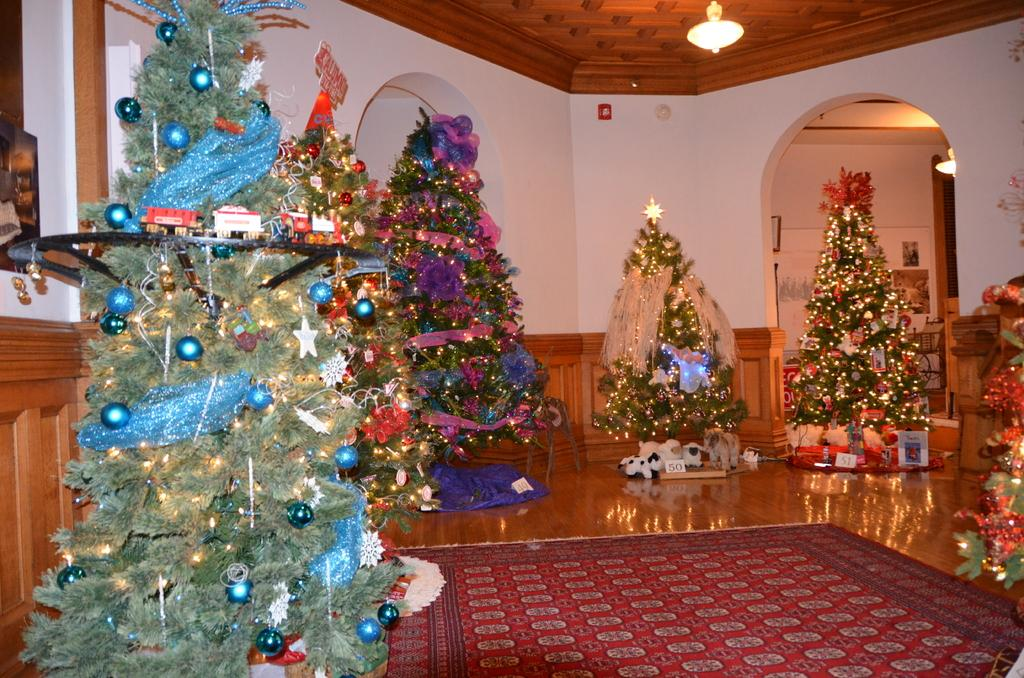What type of decorations are present in the image? There are Christmas trees in the image. What is located at the bottom of the image? There is a carpet at the bottom of the image. Where is the light source in the image? There is a light on the ceiling, which is at the top of the image. What type of pet can be seen playing with a hole in the image? There is no pet or hole present in the image. 